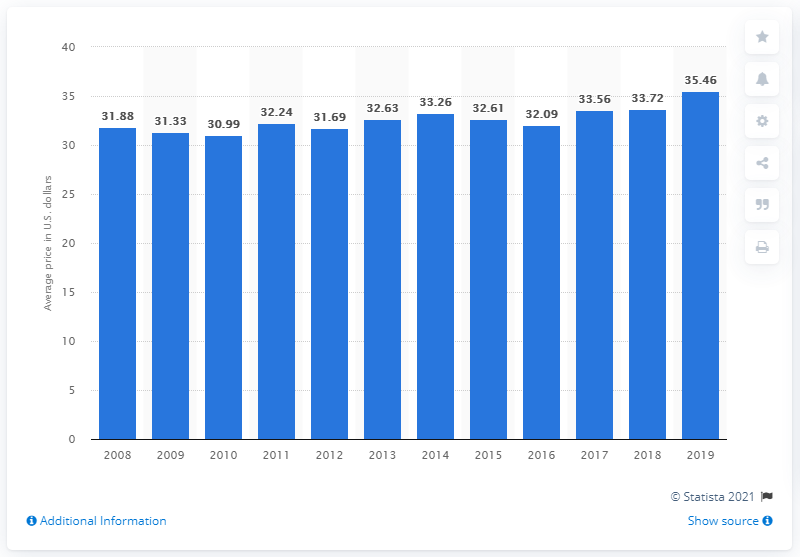List a handful of essential elements in this visual. The average cost of a pedicure in the United States in 2019 was 35.46 dollars. 